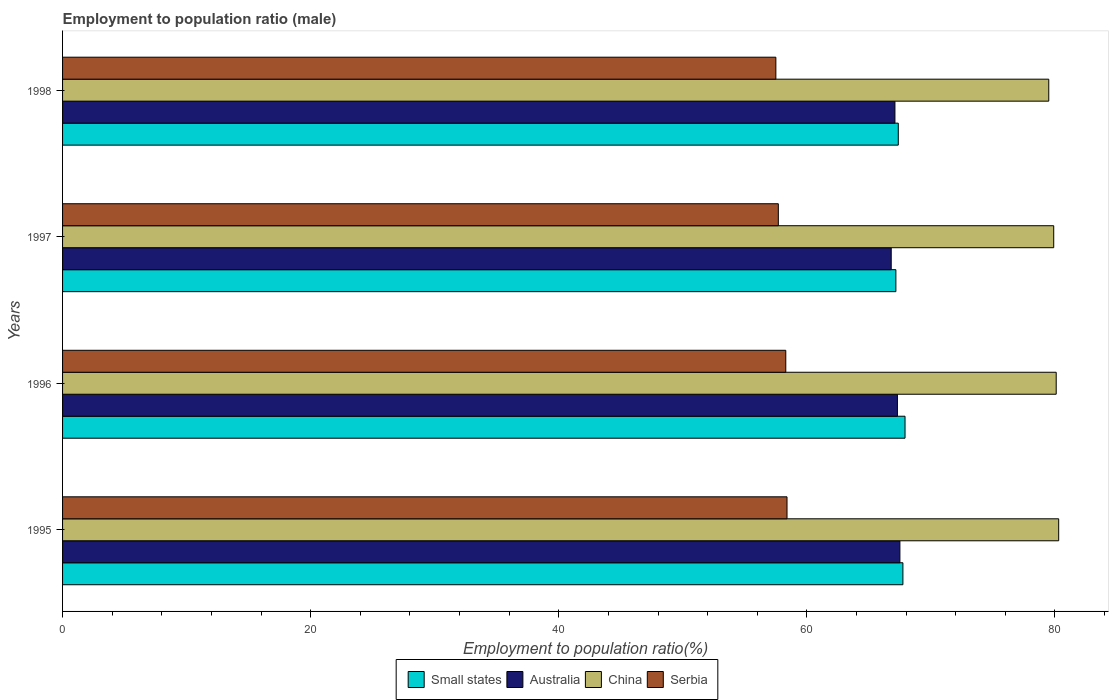Are the number of bars per tick equal to the number of legend labels?
Your answer should be compact. Yes. Are the number of bars on each tick of the Y-axis equal?
Ensure brevity in your answer.  Yes. How many bars are there on the 3rd tick from the top?
Your answer should be compact. 4. What is the employment to population ratio in China in 1998?
Provide a succinct answer. 79.5. Across all years, what is the maximum employment to population ratio in Serbia?
Make the answer very short. 58.4. Across all years, what is the minimum employment to population ratio in Serbia?
Keep it short and to the point. 57.5. In which year was the employment to population ratio in Small states minimum?
Provide a succinct answer. 1997. What is the total employment to population ratio in Serbia in the graph?
Your response must be concise. 231.9. What is the difference between the employment to population ratio in Australia in 1995 and that in 1997?
Ensure brevity in your answer.  0.7. What is the difference between the employment to population ratio in China in 1996 and the employment to population ratio in Small states in 1998?
Offer a very short reply. 12.73. What is the average employment to population ratio in Serbia per year?
Your answer should be compact. 57.98. In the year 1996, what is the difference between the employment to population ratio in Serbia and employment to population ratio in Small states?
Offer a terse response. -9.61. What is the ratio of the employment to population ratio in China in 1996 to that in 1998?
Provide a succinct answer. 1.01. Is the employment to population ratio in Small states in 1995 less than that in 1998?
Offer a very short reply. No. Is the difference between the employment to population ratio in Serbia in 1995 and 1998 greater than the difference between the employment to population ratio in Small states in 1995 and 1998?
Your answer should be very brief. Yes. What is the difference between the highest and the second highest employment to population ratio in Small states?
Offer a very short reply. 0.17. What is the difference between the highest and the lowest employment to population ratio in Serbia?
Keep it short and to the point. 0.9. In how many years, is the employment to population ratio in Small states greater than the average employment to population ratio in Small states taken over all years?
Your answer should be very brief. 2. What does the 2nd bar from the bottom in 1997 represents?
Your answer should be compact. Australia. How many bars are there?
Give a very brief answer. 16. Does the graph contain grids?
Ensure brevity in your answer.  No. How many legend labels are there?
Provide a succinct answer. 4. How are the legend labels stacked?
Your response must be concise. Horizontal. What is the title of the graph?
Offer a terse response. Employment to population ratio (male). What is the label or title of the Y-axis?
Your response must be concise. Years. What is the Employment to population ratio(%) in Small states in 1995?
Make the answer very short. 67.74. What is the Employment to population ratio(%) of Australia in 1995?
Give a very brief answer. 67.5. What is the Employment to population ratio(%) of China in 1995?
Keep it short and to the point. 80.3. What is the Employment to population ratio(%) in Serbia in 1995?
Keep it short and to the point. 58.4. What is the Employment to population ratio(%) of Small states in 1996?
Provide a short and direct response. 67.91. What is the Employment to population ratio(%) in Australia in 1996?
Offer a very short reply. 67.3. What is the Employment to population ratio(%) in China in 1996?
Your answer should be very brief. 80.1. What is the Employment to population ratio(%) of Serbia in 1996?
Your answer should be very brief. 58.3. What is the Employment to population ratio(%) in Small states in 1997?
Your answer should be compact. 67.17. What is the Employment to population ratio(%) of Australia in 1997?
Give a very brief answer. 66.8. What is the Employment to population ratio(%) of China in 1997?
Offer a terse response. 79.9. What is the Employment to population ratio(%) in Serbia in 1997?
Your response must be concise. 57.7. What is the Employment to population ratio(%) of Small states in 1998?
Your answer should be compact. 67.37. What is the Employment to population ratio(%) of Australia in 1998?
Keep it short and to the point. 67.1. What is the Employment to population ratio(%) in China in 1998?
Ensure brevity in your answer.  79.5. What is the Employment to population ratio(%) in Serbia in 1998?
Your answer should be very brief. 57.5. Across all years, what is the maximum Employment to population ratio(%) of Small states?
Your response must be concise. 67.91. Across all years, what is the maximum Employment to population ratio(%) of Australia?
Ensure brevity in your answer.  67.5. Across all years, what is the maximum Employment to population ratio(%) in China?
Offer a terse response. 80.3. Across all years, what is the maximum Employment to population ratio(%) of Serbia?
Make the answer very short. 58.4. Across all years, what is the minimum Employment to population ratio(%) in Small states?
Offer a terse response. 67.17. Across all years, what is the minimum Employment to population ratio(%) in Australia?
Offer a very short reply. 66.8. Across all years, what is the minimum Employment to population ratio(%) in China?
Provide a succinct answer. 79.5. Across all years, what is the minimum Employment to population ratio(%) of Serbia?
Your answer should be compact. 57.5. What is the total Employment to population ratio(%) in Small states in the graph?
Offer a terse response. 270.2. What is the total Employment to population ratio(%) in Australia in the graph?
Give a very brief answer. 268.7. What is the total Employment to population ratio(%) of China in the graph?
Make the answer very short. 319.8. What is the total Employment to population ratio(%) of Serbia in the graph?
Make the answer very short. 231.9. What is the difference between the Employment to population ratio(%) in Small states in 1995 and that in 1996?
Keep it short and to the point. -0.17. What is the difference between the Employment to population ratio(%) of Small states in 1995 and that in 1997?
Provide a short and direct response. 0.57. What is the difference between the Employment to population ratio(%) of Australia in 1995 and that in 1997?
Ensure brevity in your answer.  0.7. What is the difference between the Employment to population ratio(%) in Serbia in 1995 and that in 1997?
Provide a succinct answer. 0.7. What is the difference between the Employment to population ratio(%) in Small states in 1995 and that in 1998?
Provide a short and direct response. 0.37. What is the difference between the Employment to population ratio(%) in China in 1995 and that in 1998?
Provide a succinct answer. 0.8. What is the difference between the Employment to population ratio(%) of Small states in 1996 and that in 1997?
Give a very brief answer. 0.74. What is the difference between the Employment to population ratio(%) in Australia in 1996 and that in 1997?
Provide a succinct answer. 0.5. What is the difference between the Employment to population ratio(%) of Small states in 1996 and that in 1998?
Provide a short and direct response. 0.54. What is the difference between the Employment to population ratio(%) in Australia in 1996 and that in 1998?
Your response must be concise. 0.2. What is the difference between the Employment to population ratio(%) in Small states in 1997 and that in 1998?
Provide a succinct answer. -0.19. What is the difference between the Employment to population ratio(%) of Serbia in 1997 and that in 1998?
Offer a terse response. 0.2. What is the difference between the Employment to population ratio(%) of Small states in 1995 and the Employment to population ratio(%) of Australia in 1996?
Your answer should be very brief. 0.44. What is the difference between the Employment to population ratio(%) in Small states in 1995 and the Employment to population ratio(%) in China in 1996?
Give a very brief answer. -12.36. What is the difference between the Employment to population ratio(%) in Small states in 1995 and the Employment to population ratio(%) in Serbia in 1996?
Provide a succinct answer. 9.44. What is the difference between the Employment to population ratio(%) in Australia in 1995 and the Employment to population ratio(%) in China in 1996?
Make the answer very short. -12.6. What is the difference between the Employment to population ratio(%) of China in 1995 and the Employment to population ratio(%) of Serbia in 1996?
Your answer should be very brief. 22. What is the difference between the Employment to population ratio(%) of Small states in 1995 and the Employment to population ratio(%) of Australia in 1997?
Make the answer very short. 0.94. What is the difference between the Employment to population ratio(%) of Small states in 1995 and the Employment to population ratio(%) of China in 1997?
Your answer should be compact. -12.16. What is the difference between the Employment to population ratio(%) of Small states in 1995 and the Employment to population ratio(%) of Serbia in 1997?
Provide a short and direct response. 10.04. What is the difference between the Employment to population ratio(%) in Australia in 1995 and the Employment to population ratio(%) in China in 1997?
Offer a very short reply. -12.4. What is the difference between the Employment to population ratio(%) in Australia in 1995 and the Employment to population ratio(%) in Serbia in 1997?
Provide a short and direct response. 9.8. What is the difference between the Employment to population ratio(%) of China in 1995 and the Employment to population ratio(%) of Serbia in 1997?
Keep it short and to the point. 22.6. What is the difference between the Employment to population ratio(%) in Small states in 1995 and the Employment to population ratio(%) in Australia in 1998?
Your answer should be compact. 0.64. What is the difference between the Employment to population ratio(%) in Small states in 1995 and the Employment to population ratio(%) in China in 1998?
Ensure brevity in your answer.  -11.76. What is the difference between the Employment to population ratio(%) of Small states in 1995 and the Employment to population ratio(%) of Serbia in 1998?
Your response must be concise. 10.24. What is the difference between the Employment to population ratio(%) of China in 1995 and the Employment to population ratio(%) of Serbia in 1998?
Ensure brevity in your answer.  22.8. What is the difference between the Employment to population ratio(%) in Small states in 1996 and the Employment to population ratio(%) in Australia in 1997?
Keep it short and to the point. 1.11. What is the difference between the Employment to population ratio(%) of Small states in 1996 and the Employment to population ratio(%) of China in 1997?
Offer a terse response. -11.99. What is the difference between the Employment to population ratio(%) of Small states in 1996 and the Employment to population ratio(%) of Serbia in 1997?
Offer a very short reply. 10.21. What is the difference between the Employment to population ratio(%) in Australia in 1996 and the Employment to population ratio(%) in China in 1997?
Your answer should be compact. -12.6. What is the difference between the Employment to population ratio(%) in China in 1996 and the Employment to population ratio(%) in Serbia in 1997?
Your response must be concise. 22.4. What is the difference between the Employment to population ratio(%) in Small states in 1996 and the Employment to population ratio(%) in Australia in 1998?
Ensure brevity in your answer.  0.81. What is the difference between the Employment to population ratio(%) in Small states in 1996 and the Employment to population ratio(%) in China in 1998?
Your response must be concise. -11.59. What is the difference between the Employment to population ratio(%) in Small states in 1996 and the Employment to population ratio(%) in Serbia in 1998?
Make the answer very short. 10.41. What is the difference between the Employment to population ratio(%) of Australia in 1996 and the Employment to population ratio(%) of China in 1998?
Make the answer very short. -12.2. What is the difference between the Employment to population ratio(%) of Australia in 1996 and the Employment to population ratio(%) of Serbia in 1998?
Ensure brevity in your answer.  9.8. What is the difference between the Employment to population ratio(%) in China in 1996 and the Employment to population ratio(%) in Serbia in 1998?
Your answer should be compact. 22.6. What is the difference between the Employment to population ratio(%) in Small states in 1997 and the Employment to population ratio(%) in Australia in 1998?
Your answer should be compact. 0.07. What is the difference between the Employment to population ratio(%) in Small states in 1997 and the Employment to population ratio(%) in China in 1998?
Your answer should be very brief. -12.32. What is the difference between the Employment to population ratio(%) in Small states in 1997 and the Employment to population ratio(%) in Serbia in 1998?
Offer a very short reply. 9.68. What is the difference between the Employment to population ratio(%) in Australia in 1997 and the Employment to population ratio(%) in Serbia in 1998?
Make the answer very short. 9.3. What is the difference between the Employment to population ratio(%) of China in 1997 and the Employment to population ratio(%) of Serbia in 1998?
Offer a terse response. 22.4. What is the average Employment to population ratio(%) in Small states per year?
Make the answer very short. 67.55. What is the average Employment to population ratio(%) of Australia per year?
Give a very brief answer. 67.17. What is the average Employment to population ratio(%) in China per year?
Provide a succinct answer. 79.95. What is the average Employment to population ratio(%) in Serbia per year?
Your response must be concise. 57.98. In the year 1995, what is the difference between the Employment to population ratio(%) of Small states and Employment to population ratio(%) of Australia?
Your answer should be compact. 0.24. In the year 1995, what is the difference between the Employment to population ratio(%) of Small states and Employment to population ratio(%) of China?
Offer a terse response. -12.56. In the year 1995, what is the difference between the Employment to population ratio(%) in Small states and Employment to population ratio(%) in Serbia?
Provide a short and direct response. 9.34. In the year 1995, what is the difference between the Employment to population ratio(%) in Australia and Employment to population ratio(%) in China?
Your response must be concise. -12.8. In the year 1995, what is the difference between the Employment to population ratio(%) in Australia and Employment to population ratio(%) in Serbia?
Make the answer very short. 9.1. In the year 1995, what is the difference between the Employment to population ratio(%) of China and Employment to population ratio(%) of Serbia?
Offer a very short reply. 21.9. In the year 1996, what is the difference between the Employment to population ratio(%) of Small states and Employment to population ratio(%) of Australia?
Make the answer very short. 0.61. In the year 1996, what is the difference between the Employment to population ratio(%) in Small states and Employment to population ratio(%) in China?
Keep it short and to the point. -12.19. In the year 1996, what is the difference between the Employment to population ratio(%) in Small states and Employment to population ratio(%) in Serbia?
Provide a succinct answer. 9.61. In the year 1996, what is the difference between the Employment to population ratio(%) of China and Employment to population ratio(%) of Serbia?
Provide a succinct answer. 21.8. In the year 1997, what is the difference between the Employment to population ratio(%) in Small states and Employment to population ratio(%) in China?
Provide a short and direct response. -12.72. In the year 1997, what is the difference between the Employment to population ratio(%) in Small states and Employment to population ratio(%) in Serbia?
Ensure brevity in your answer.  9.47. In the year 1997, what is the difference between the Employment to population ratio(%) in Australia and Employment to population ratio(%) in China?
Your answer should be compact. -13.1. In the year 1997, what is the difference between the Employment to population ratio(%) in China and Employment to population ratio(%) in Serbia?
Give a very brief answer. 22.2. In the year 1998, what is the difference between the Employment to population ratio(%) in Small states and Employment to population ratio(%) in Australia?
Ensure brevity in your answer.  0.27. In the year 1998, what is the difference between the Employment to population ratio(%) in Small states and Employment to population ratio(%) in China?
Keep it short and to the point. -12.13. In the year 1998, what is the difference between the Employment to population ratio(%) in Small states and Employment to population ratio(%) in Serbia?
Ensure brevity in your answer.  9.87. What is the ratio of the Employment to population ratio(%) of Small states in 1995 to that in 1996?
Give a very brief answer. 1. What is the ratio of the Employment to population ratio(%) in China in 1995 to that in 1996?
Offer a terse response. 1. What is the ratio of the Employment to population ratio(%) in Small states in 1995 to that in 1997?
Keep it short and to the point. 1.01. What is the ratio of the Employment to population ratio(%) of Australia in 1995 to that in 1997?
Your answer should be compact. 1.01. What is the ratio of the Employment to population ratio(%) of China in 1995 to that in 1997?
Your response must be concise. 1. What is the ratio of the Employment to population ratio(%) of Serbia in 1995 to that in 1997?
Make the answer very short. 1.01. What is the ratio of the Employment to population ratio(%) in Australia in 1995 to that in 1998?
Give a very brief answer. 1.01. What is the ratio of the Employment to population ratio(%) of China in 1995 to that in 1998?
Offer a terse response. 1.01. What is the ratio of the Employment to population ratio(%) of Serbia in 1995 to that in 1998?
Make the answer very short. 1.02. What is the ratio of the Employment to population ratio(%) in Small states in 1996 to that in 1997?
Give a very brief answer. 1.01. What is the ratio of the Employment to population ratio(%) in Australia in 1996 to that in 1997?
Offer a terse response. 1.01. What is the ratio of the Employment to population ratio(%) of China in 1996 to that in 1997?
Give a very brief answer. 1. What is the ratio of the Employment to population ratio(%) in Serbia in 1996 to that in 1997?
Ensure brevity in your answer.  1.01. What is the ratio of the Employment to population ratio(%) of Small states in 1996 to that in 1998?
Your answer should be compact. 1.01. What is the ratio of the Employment to population ratio(%) of Australia in 1996 to that in 1998?
Your answer should be compact. 1. What is the ratio of the Employment to population ratio(%) in China in 1996 to that in 1998?
Your response must be concise. 1.01. What is the ratio of the Employment to population ratio(%) of Serbia in 1996 to that in 1998?
Offer a terse response. 1.01. What is the ratio of the Employment to population ratio(%) in Australia in 1997 to that in 1998?
Give a very brief answer. 1. What is the ratio of the Employment to population ratio(%) of China in 1997 to that in 1998?
Keep it short and to the point. 1. What is the ratio of the Employment to population ratio(%) in Serbia in 1997 to that in 1998?
Make the answer very short. 1. What is the difference between the highest and the second highest Employment to population ratio(%) in Small states?
Your answer should be very brief. 0.17. What is the difference between the highest and the second highest Employment to population ratio(%) in Australia?
Your answer should be very brief. 0.2. What is the difference between the highest and the lowest Employment to population ratio(%) in Small states?
Your answer should be compact. 0.74. What is the difference between the highest and the lowest Employment to population ratio(%) in Australia?
Your answer should be compact. 0.7. What is the difference between the highest and the lowest Employment to population ratio(%) in China?
Provide a succinct answer. 0.8. What is the difference between the highest and the lowest Employment to population ratio(%) of Serbia?
Offer a terse response. 0.9. 